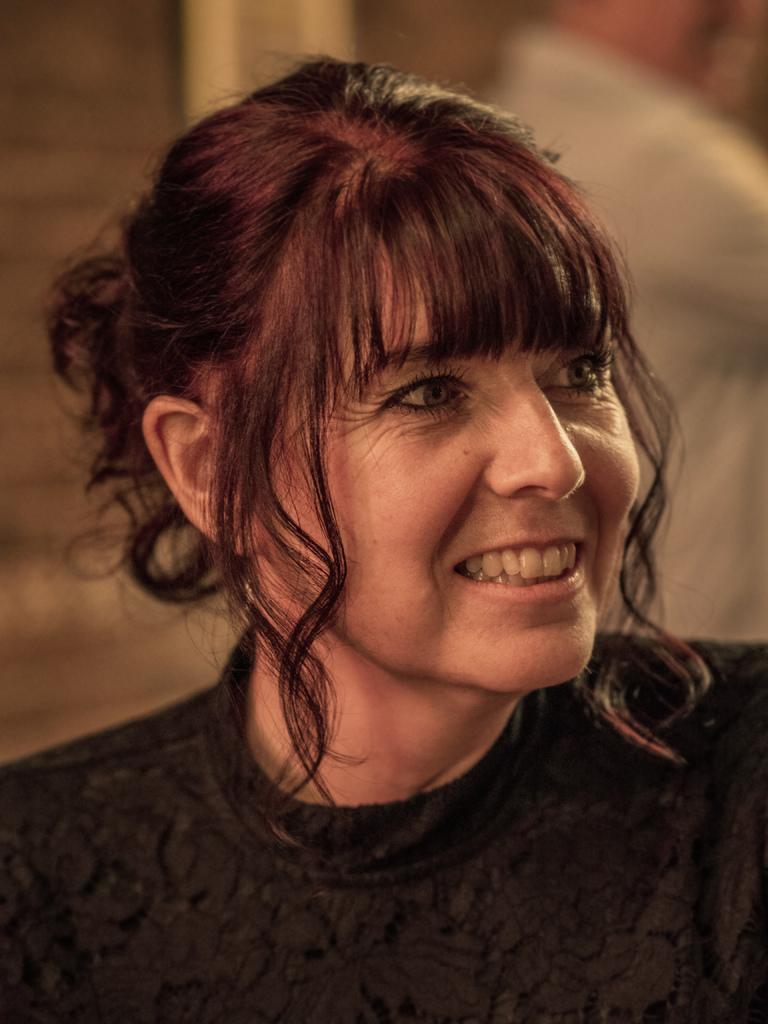In one or two sentences, can you explain what this image depicts? In this picture we can see a woman, she is smiling and in the background we can see it is blurry. 